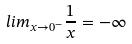<formula> <loc_0><loc_0><loc_500><loc_500>l i m _ { x \rightarrow 0 ^ { - } } \frac { 1 } { x } = - \infty</formula> 